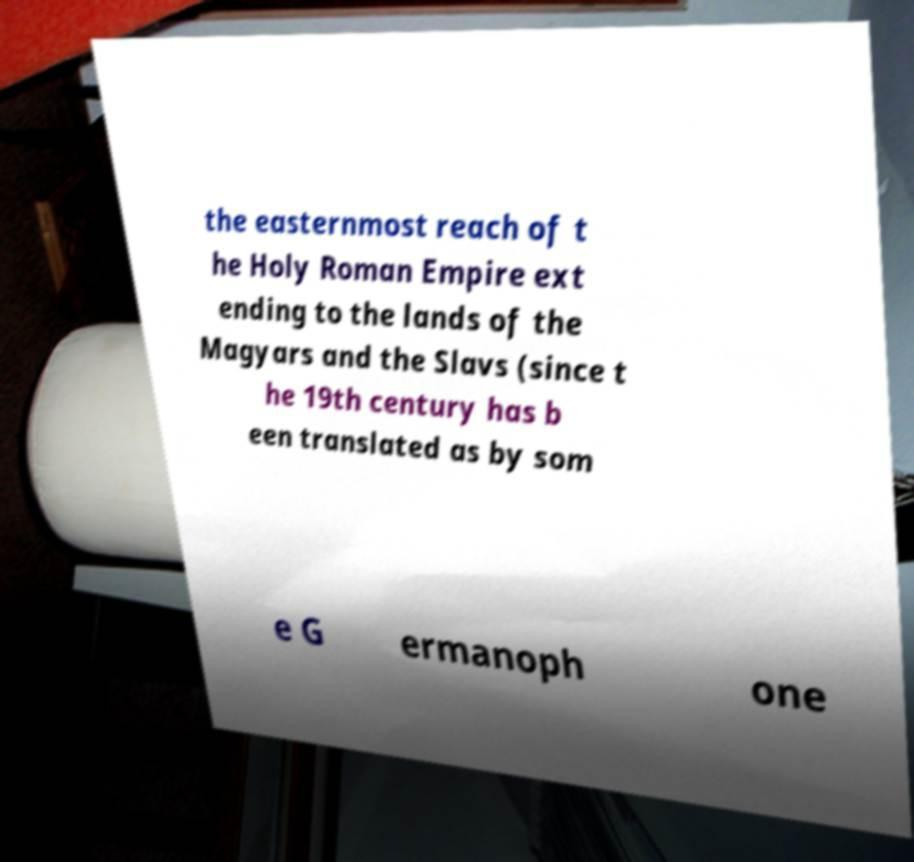Please identify and transcribe the text found in this image. the easternmost reach of t he Holy Roman Empire ext ending to the lands of the Magyars and the Slavs (since t he 19th century has b een translated as by som e G ermanoph one 